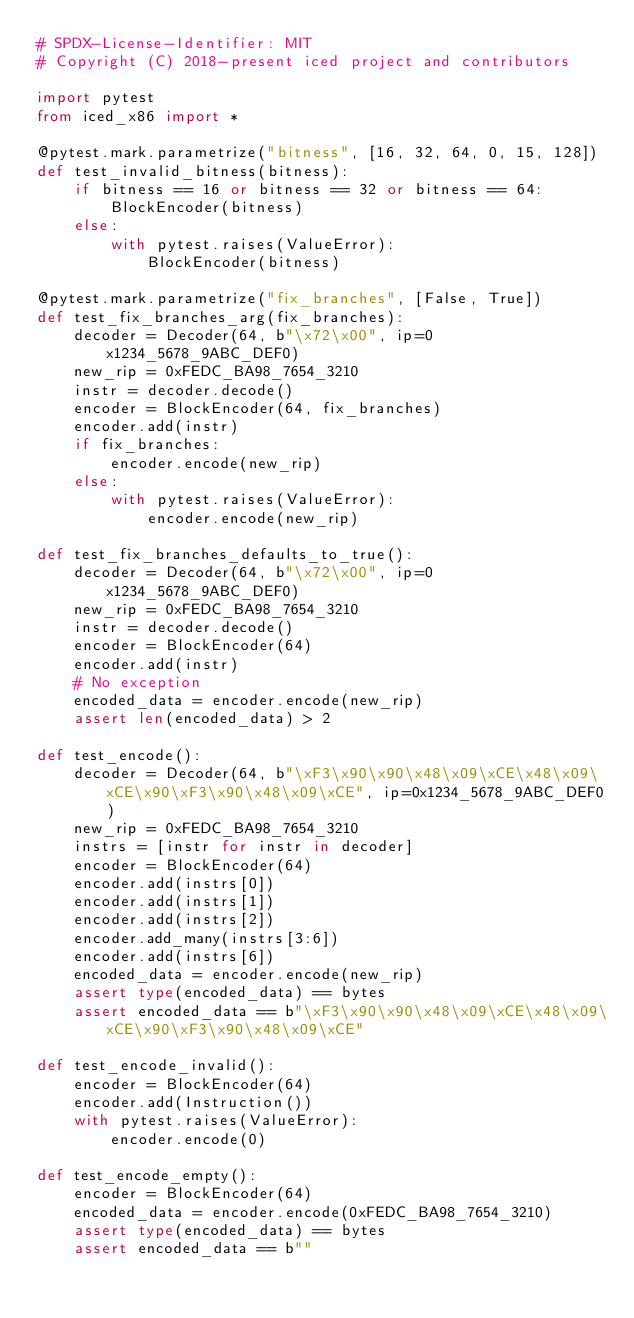<code> <loc_0><loc_0><loc_500><loc_500><_Python_># SPDX-License-Identifier: MIT
# Copyright (C) 2018-present iced project and contributors

import pytest
from iced_x86 import *

@pytest.mark.parametrize("bitness", [16, 32, 64, 0, 15, 128])
def test_invalid_bitness(bitness):
	if bitness == 16 or bitness == 32 or bitness == 64:
		BlockEncoder(bitness)
	else:
		with pytest.raises(ValueError):
			BlockEncoder(bitness)

@pytest.mark.parametrize("fix_branches", [False, True])
def test_fix_branches_arg(fix_branches):
	decoder = Decoder(64, b"\x72\x00", ip=0x1234_5678_9ABC_DEF0)
	new_rip = 0xFEDC_BA98_7654_3210
	instr = decoder.decode()
	encoder = BlockEncoder(64, fix_branches)
	encoder.add(instr)
	if fix_branches:
		encoder.encode(new_rip)
	else:
		with pytest.raises(ValueError):
			encoder.encode(new_rip)

def test_fix_branches_defaults_to_true():
	decoder = Decoder(64, b"\x72\x00", ip=0x1234_5678_9ABC_DEF0)
	new_rip = 0xFEDC_BA98_7654_3210
	instr = decoder.decode()
	encoder = BlockEncoder(64)
	encoder.add(instr)
	# No exception
	encoded_data = encoder.encode(new_rip)
	assert len(encoded_data) > 2

def test_encode():
	decoder = Decoder(64, b"\xF3\x90\x90\x48\x09\xCE\x48\x09\xCE\x90\xF3\x90\x48\x09\xCE", ip=0x1234_5678_9ABC_DEF0)
	new_rip = 0xFEDC_BA98_7654_3210
	instrs = [instr for instr in decoder]
	encoder = BlockEncoder(64)
	encoder.add(instrs[0])
	encoder.add(instrs[1])
	encoder.add(instrs[2])
	encoder.add_many(instrs[3:6])
	encoder.add(instrs[6])
	encoded_data = encoder.encode(new_rip)
	assert type(encoded_data) == bytes
	assert encoded_data == b"\xF3\x90\x90\x48\x09\xCE\x48\x09\xCE\x90\xF3\x90\x48\x09\xCE"

def test_encode_invalid():
	encoder = BlockEncoder(64)
	encoder.add(Instruction())
	with pytest.raises(ValueError):
		encoder.encode(0)

def test_encode_empty():
	encoder = BlockEncoder(64)
	encoded_data = encoder.encode(0xFEDC_BA98_7654_3210)
	assert type(encoded_data) == bytes
	assert encoded_data == b""
</code> 